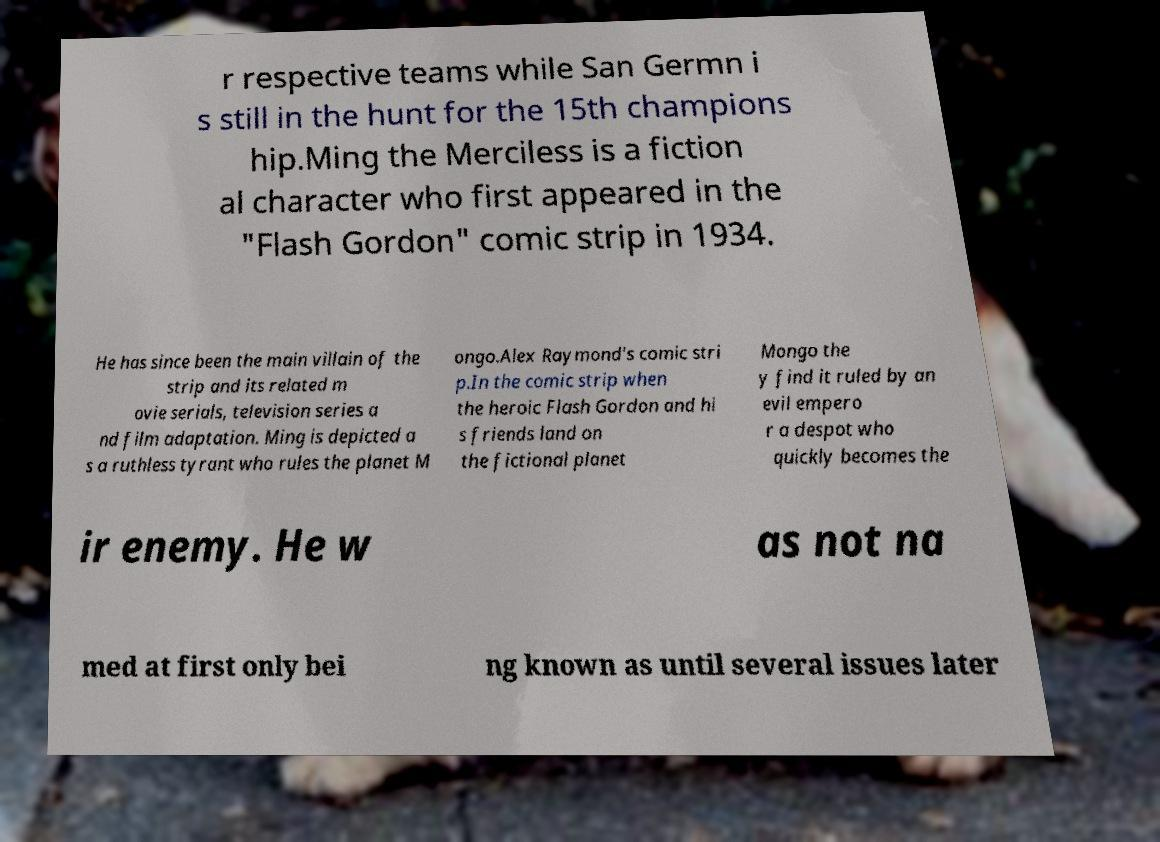Please read and relay the text visible in this image. What does it say? r respective teams while San Germn i s still in the hunt for the 15th champions hip.Ming the Merciless is a fiction al character who first appeared in the "Flash Gordon" comic strip in 1934. He has since been the main villain of the strip and its related m ovie serials, television series a nd film adaptation. Ming is depicted a s a ruthless tyrant who rules the planet M ongo.Alex Raymond's comic stri p.In the comic strip when the heroic Flash Gordon and hi s friends land on the fictional planet Mongo the y find it ruled by an evil empero r a despot who quickly becomes the ir enemy. He w as not na med at first only bei ng known as until several issues later 